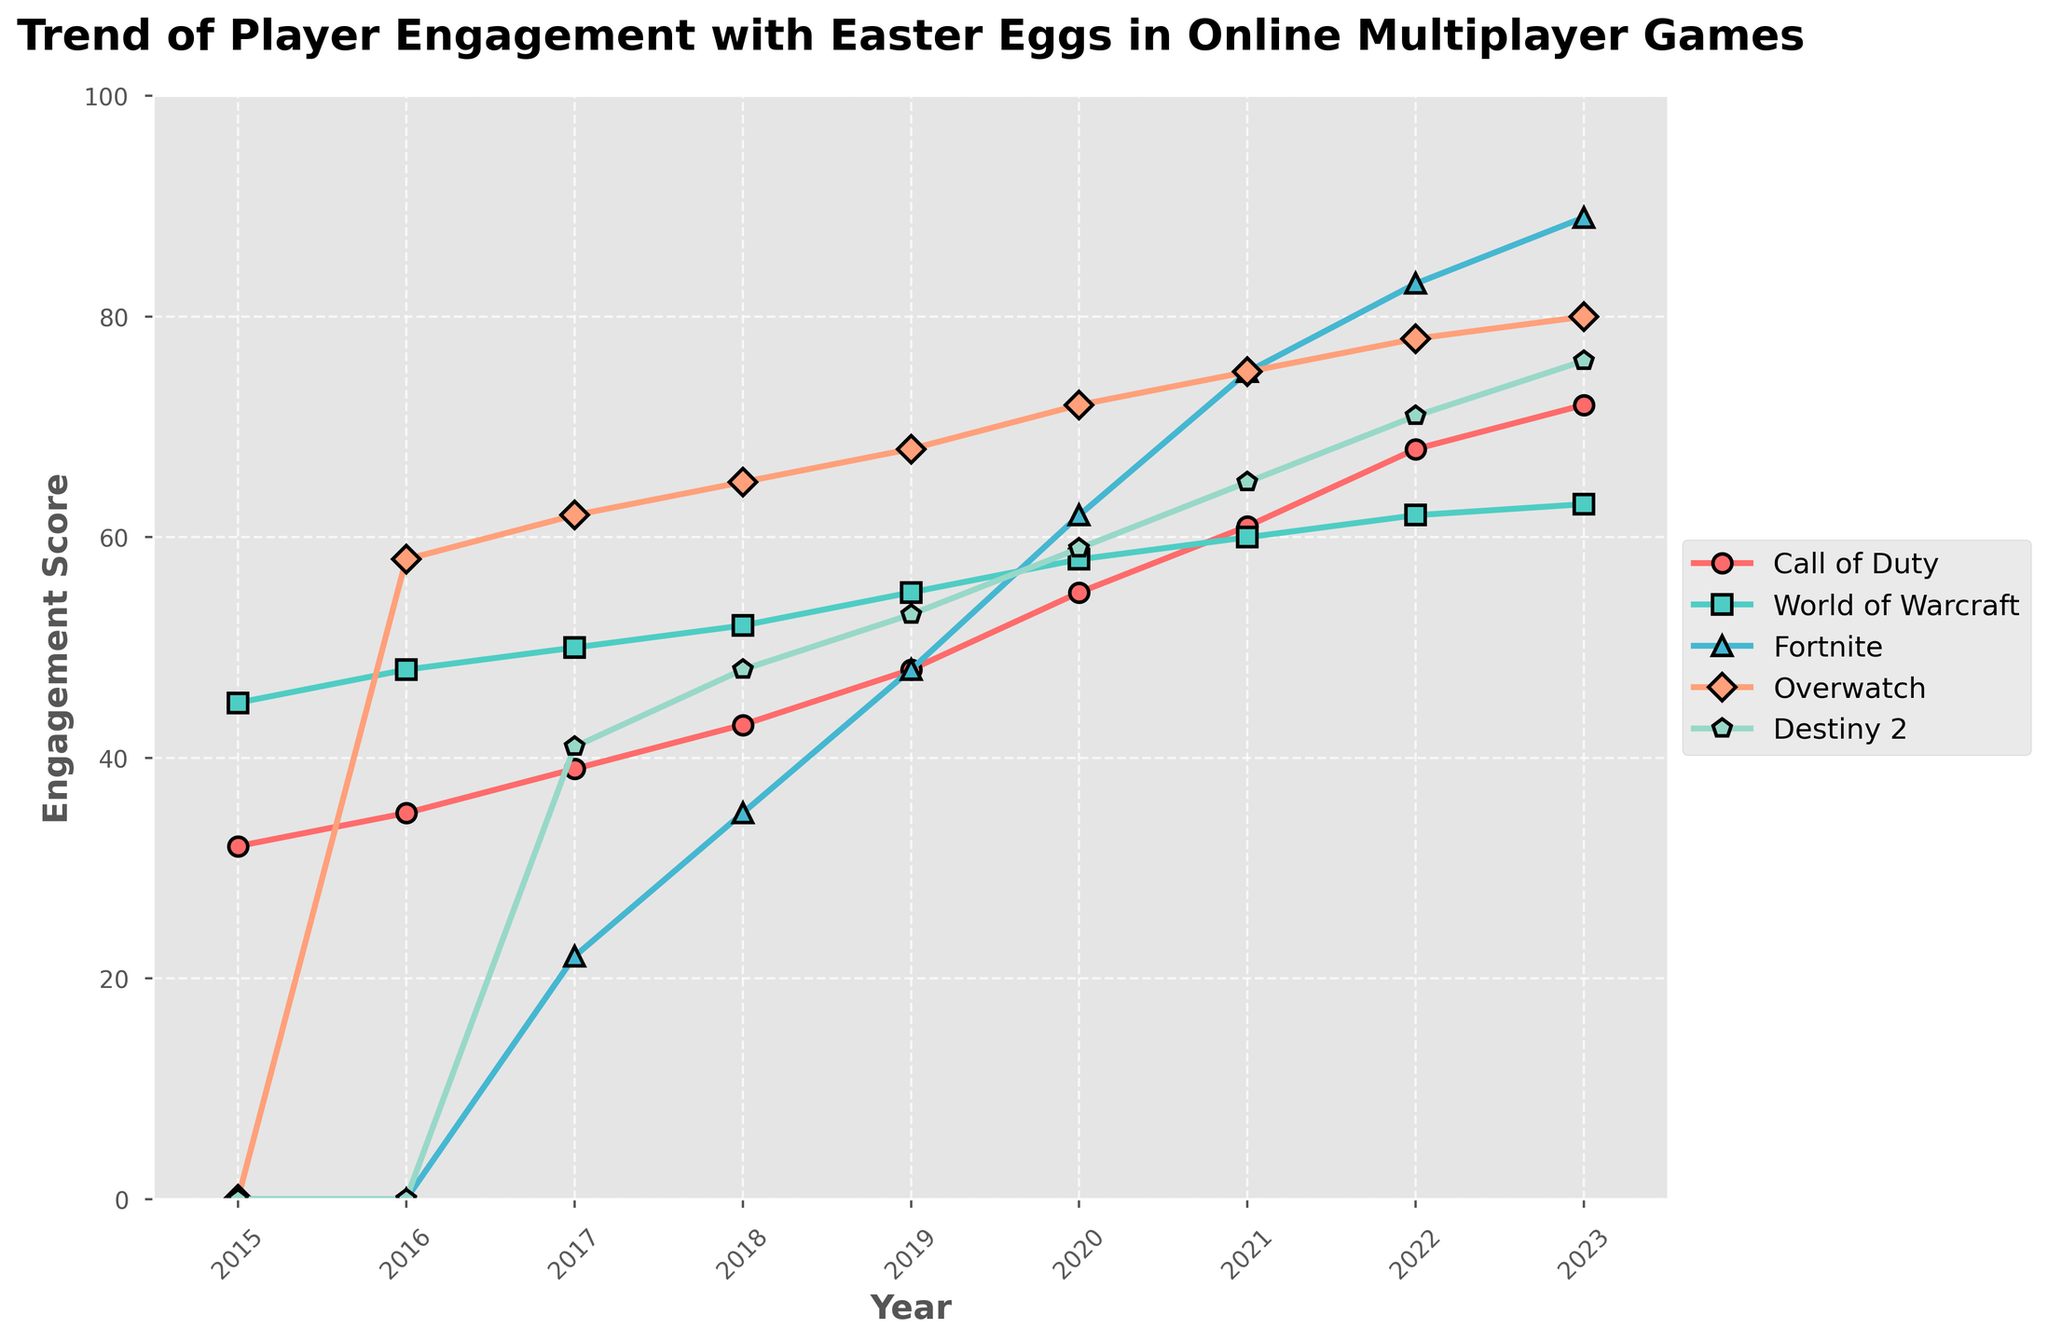What year did "Fortnite" see the most engagement? The engagement score for "Fortnite" peaks at its highest value in the year 2023 on the line chart.
Answer: 2023 Which game had the lowest engagement score in 2015? In 2015, the engagement scores for "Call of Duty", "World of Warcraft", "Fortnite", "Overwatch", and "Destiny 2" were 32, 45, 0, 0, and 0, respectively. "Fortnite", "Overwatch", and "Destiny 2" had the lowest score of 0.
Answer: Fortnite, Overwatch, Destiny 2 How did the engagement of "Destiny 2" change from 2017 to 2018? In 2017, "Destiny 2" had an engagement score of 41, and in 2018, it increased to 48. So, the increase from 2017 to 2018 is 48 - 41 = 7.
Answer: Increased by 7 Which game showed the most consistent increase in engagement from 2015 to 2023? By observing the slopes of the lines, "Call of Duty" consistently rises each year from 32 in 2015 to 72 in 2023.
Answer: Call of Duty What is the average engagement score of "World of Warcraft" from 2015 to 2018? The engagement scores from 2015 to 2018 for "World of Warcraft" are 45, 48, 50, and 52. The average is (45 + 48 + 50 + 52) / 4 = 48.75.
Answer: 48.75 Compare the engagement trends of "Overwatch" and "Destiny 2" in 2016 and 2019. Which had a higher increase? "Overwatch" increased from 58 in 2016 to 68 in 2019, giving an increase of 10. "Destiny 2" moved from 0 in 2016 to 53 in 2019, providing an increase of 53. So, "Destiny 2" had a higher increase.
Answer: Destiny 2 In which year did "Fortnite" surpass the engagement score of "World of Warcraft" for the first time? The chart shows that in 2018, "Fortnite" had an engagement score of 35, while "World of Warcraft" had 52. In 2019, "Fortnite" surpassed "World of Warcraft" with an engagement score of 48 compared to 55.
Answer: 2019 By how much did the engagement score of "Call of Duty" change between 2020 and 2022? The engagement score of "Call of Duty" increased from 55 in 2020 to 68 in 2022. So the change is 68 - 55 = 13.
Answer: 13 Which game had the highest engagement score in 2021? In 2021, the engagement scores were: "Call of Duty": 61, "World of Warcraft": 60, "Fortnite": 75, "Overwatch": 75, "Destiny 2": 65. "Fortnite" and "Overwatch" had the highest score of 75.
Answer: Fortnite, Overwatch 